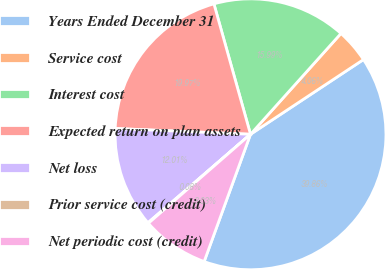<chart> <loc_0><loc_0><loc_500><loc_500><pie_chart><fcel>Years Ended December 31<fcel>Service cost<fcel>Interest cost<fcel>Expected return on plan assets<fcel>Net loss<fcel>Prior service cost (credit)<fcel>Net periodic cost (credit)<nl><fcel>39.86%<fcel>4.06%<fcel>15.99%<fcel>19.97%<fcel>12.01%<fcel>0.08%<fcel>8.03%<nl></chart> 